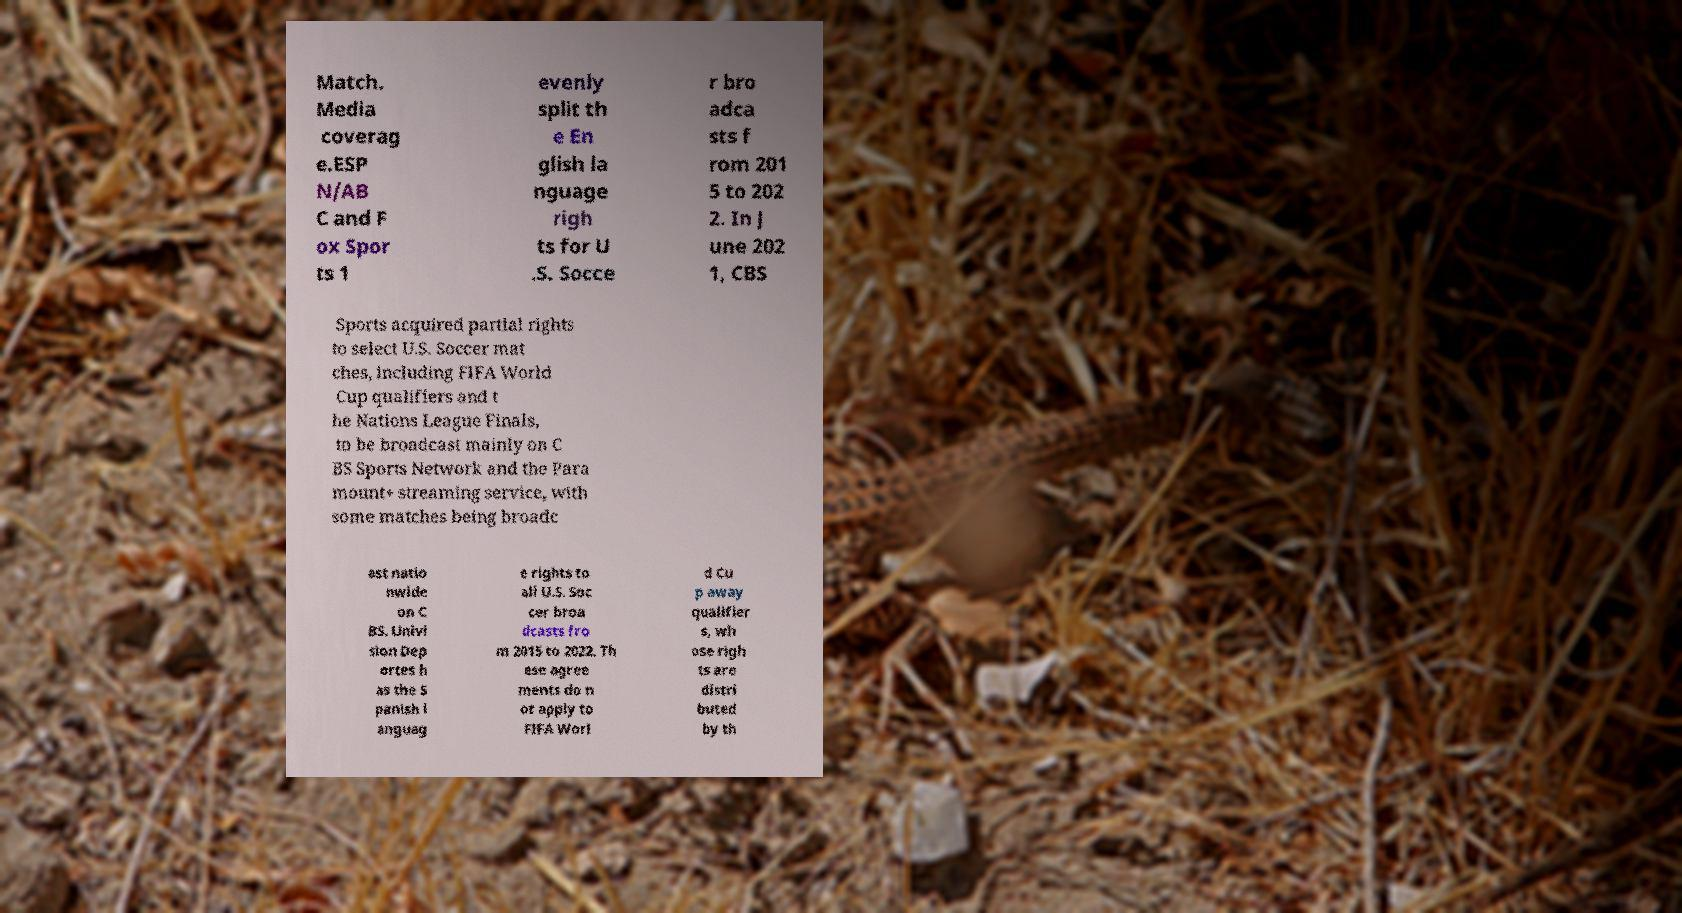I need the written content from this picture converted into text. Can you do that? Match. Media coverag e.ESP N/AB C and F ox Spor ts 1 evenly split th e En glish la nguage righ ts for U .S. Socce r bro adca sts f rom 201 5 to 202 2. In J une 202 1, CBS Sports acquired partial rights to select U.S. Soccer mat ches, including FIFA World Cup qualifiers and t he Nations League Finals, to be broadcast mainly on C BS Sports Network and the Para mount+ streaming service, with some matches being broadc ast natio nwide on C BS. Univi sion Dep ortes h as the S panish l anguag e rights to all U.S. Soc cer broa dcasts fro m 2015 to 2022. Th ese agree ments do n ot apply to FIFA Worl d Cu p away qualifier s, wh ose righ ts are distri buted by th 